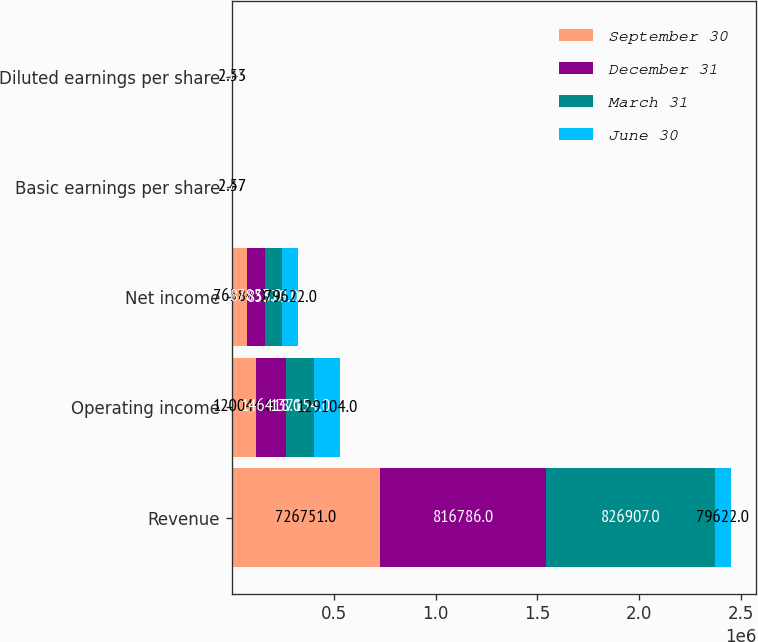Convert chart. <chart><loc_0><loc_0><loc_500><loc_500><stacked_bar_chart><ecel><fcel>Revenue<fcel>Operating income<fcel>Net income<fcel>Basic earnings per share<fcel>Diluted earnings per share<nl><fcel>September 30<fcel>726751<fcel>120044<fcel>76584<fcel>2.47<fcel>2.45<nl><fcel>December 31<fcel>816786<fcel>146418<fcel>87853<fcel>2.84<fcel>2.82<nl><fcel>March 31<fcel>826907<fcel>137154<fcel>83379<fcel>2.7<fcel>2.66<nl><fcel>June 30<fcel>79622<fcel>129104<fcel>79622<fcel>2.57<fcel>2.53<nl></chart> 